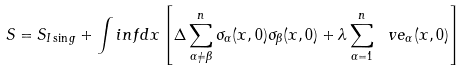<formula> <loc_0><loc_0><loc_500><loc_500>S = S _ { I \sin g } + \int i n f d x \left [ \Delta \sum _ { \alpha \neq \beta } ^ { n } \sigma _ { \alpha } ( x , 0 ) \sigma _ { \beta } ( x , 0 ) + \lambda \sum _ { \alpha = 1 } ^ { n } \ v e _ { \alpha } ( x , 0 ) \right ]</formula> 